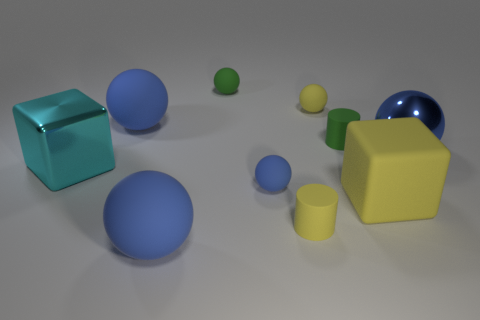There is another shiny object that is the same size as the cyan metal object; what shape is it?
Keep it short and to the point. Sphere. Is there a blue rubber object that has the same shape as the large cyan thing?
Your answer should be compact. No. Do the large cyan metallic thing left of the blue metallic ball and the small green matte object on the right side of the green ball have the same shape?
Your answer should be very brief. No. What is the material of the green ball that is the same size as the green rubber cylinder?
Provide a short and direct response. Rubber. How many other objects are the same material as the tiny blue thing?
Your answer should be very brief. 7. The green matte thing that is on the right side of the yellow rubber object that is in front of the yellow block is what shape?
Give a very brief answer. Cylinder. What number of objects are big shiny cubes or small rubber balls that are in front of the cyan metallic cube?
Make the answer very short. 2. What number of other things are the same color as the large metallic cube?
Offer a terse response. 0. What number of blue things are large spheres or big rubber balls?
Keep it short and to the point. 3. Are there any green rubber balls in front of the blue matte ball that is in front of the matte cylinder that is in front of the big yellow rubber cube?
Provide a succinct answer. No. 